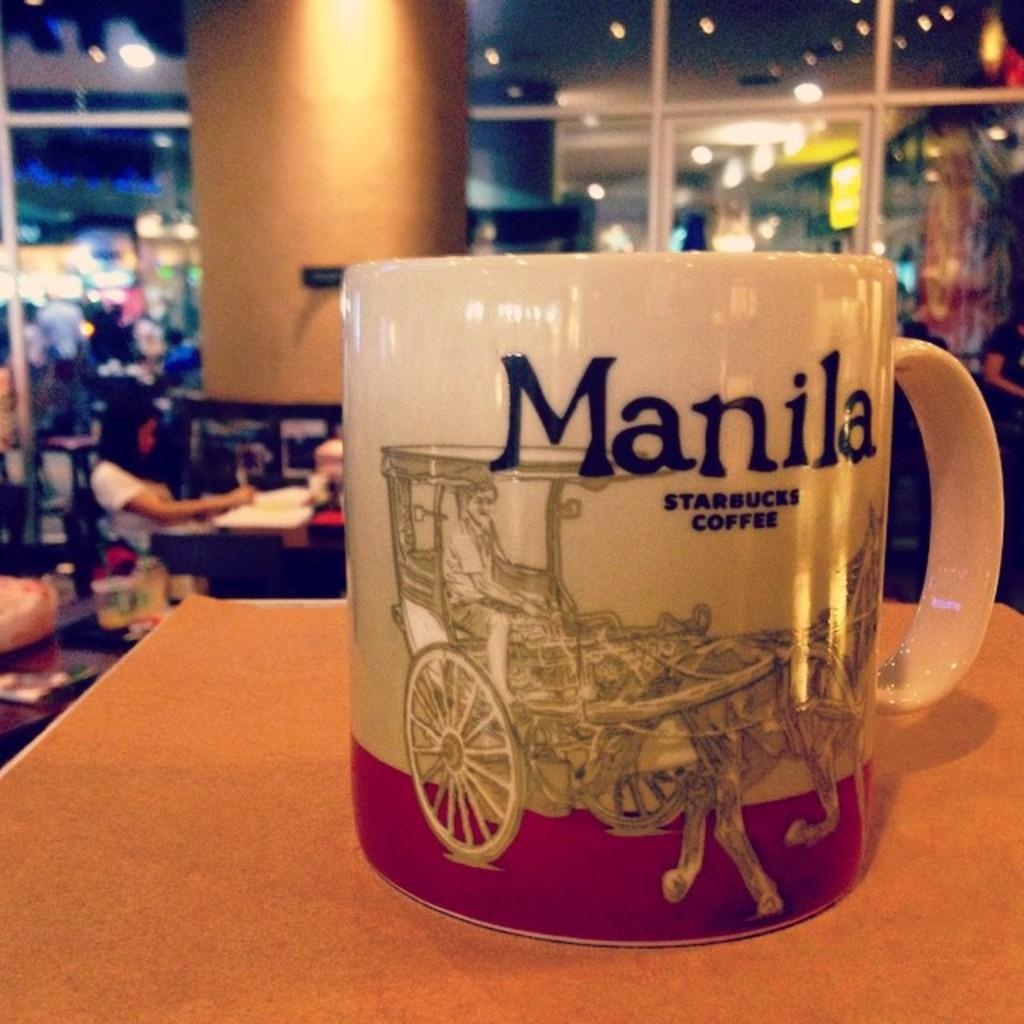What object is present in the image? There is a cup in the image. What is depicted on the cup? The cup has an art design depicting a man riding a horse cart. What type of cannon is being used by the cook in the image? There is no cannon or cook present in the image; it only features a cup with an art design. 